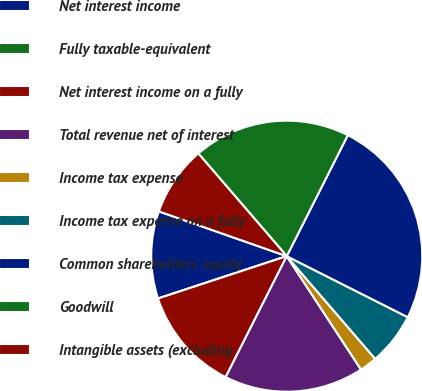<chart> <loc_0><loc_0><loc_500><loc_500><pie_chart><fcel>Net interest income<fcel>Fully taxable-equivalent<fcel>Net interest income on a fully<fcel>Total revenue net of interest<fcel>Income tax expense<fcel>Income tax expense on a fully<fcel>Common shareholders' equity<fcel>Goodwill<fcel>Intangible assets (excluding<nl><fcel>10.42%<fcel>0.0%<fcel>12.5%<fcel>16.67%<fcel>2.09%<fcel>6.25%<fcel>25.0%<fcel>18.75%<fcel>8.33%<nl></chart> 